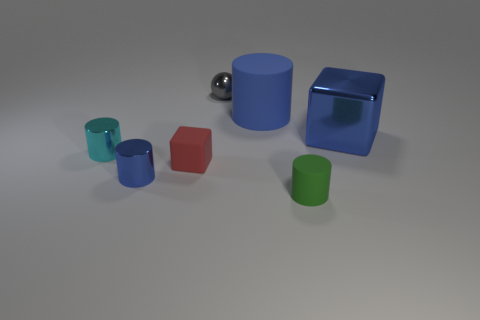Add 2 big red metal spheres. How many objects exist? 9 Subtract all cylinders. How many objects are left? 3 Add 2 red matte cylinders. How many red matte cylinders exist? 2 Subtract 0 brown cubes. How many objects are left? 7 Subtract all tiny objects. Subtract all spheres. How many objects are left? 1 Add 4 red cubes. How many red cubes are left? 5 